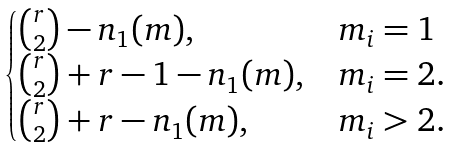Convert formula to latex. <formula><loc_0><loc_0><loc_500><loc_500>\begin{cases} \binom { r } { 2 } - n _ { 1 } ( m ) , & m _ { i } = 1 \\ \binom { r } { 2 } + r - 1 - n _ { 1 } ( m ) , & m _ { i } = 2 . \\ \binom { r } { 2 } + r - n _ { 1 } ( m ) , & m _ { i } > 2 . \end{cases}</formula> 